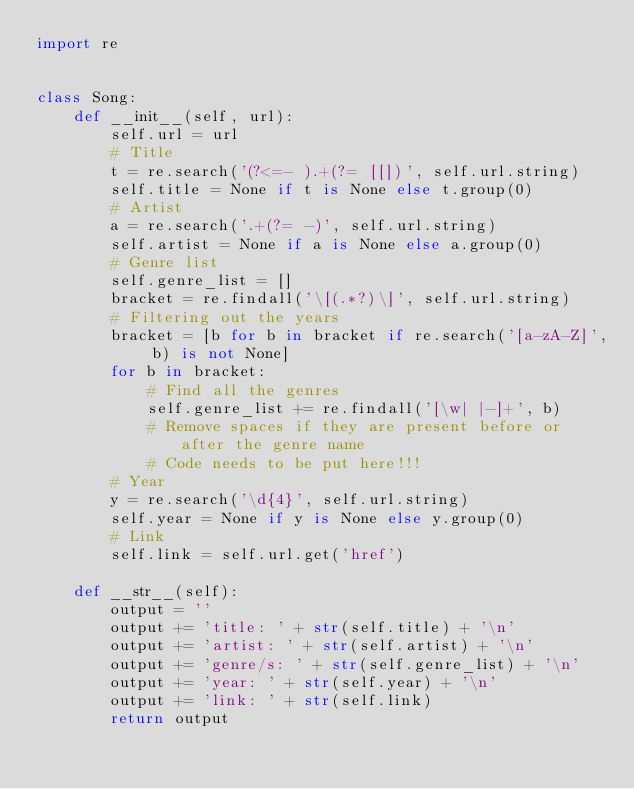<code> <loc_0><loc_0><loc_500><loc_500><_Python_>import re


class Song:
    def __init__(self, url):
        self.url = url
        # Title
        t = re.search('(?<=- ).+(?= [[])', self.url.string)
        self.title = None if t is None else t.group(0)
        # Artist
        a = re.search('.+(?= -)', self.url.string)
        self.artist = None if a is None else a.group(0)
        # Genre list
        self.genre_list = []
        bracket = re.findall('\[(.*?)\]', self.url.string)
        # Filtering out the years
        bracket = [b for b in bracket if re.search('[a-zA-Z]', b) is not None]
        for b in bracket:
            # Find all the genres
            self.genre_list += re.findall('[\w| |-]+', b)
            # Remove spaces if they are present before or after the genre name
            # Code needs to be put here!!!
        # Year
        y = re.search('\d{4}', self.url.string)
        self.year = None if y is None else y.group(0)
        # Link
        self.link = self.url.get('href')

    def __str__(self):
        output = ''
        output += 'title: ' + str(self.title) + '\n'
        output += 'artist: ' + str(self.artist) + '\n'
        output += 'genre/s: ' + str(self.genre_list) + '\n'
        output += 'year: ' + str(self.year) + '\n'
        output += 'link: ' + str(self.link)
        return output</code> 